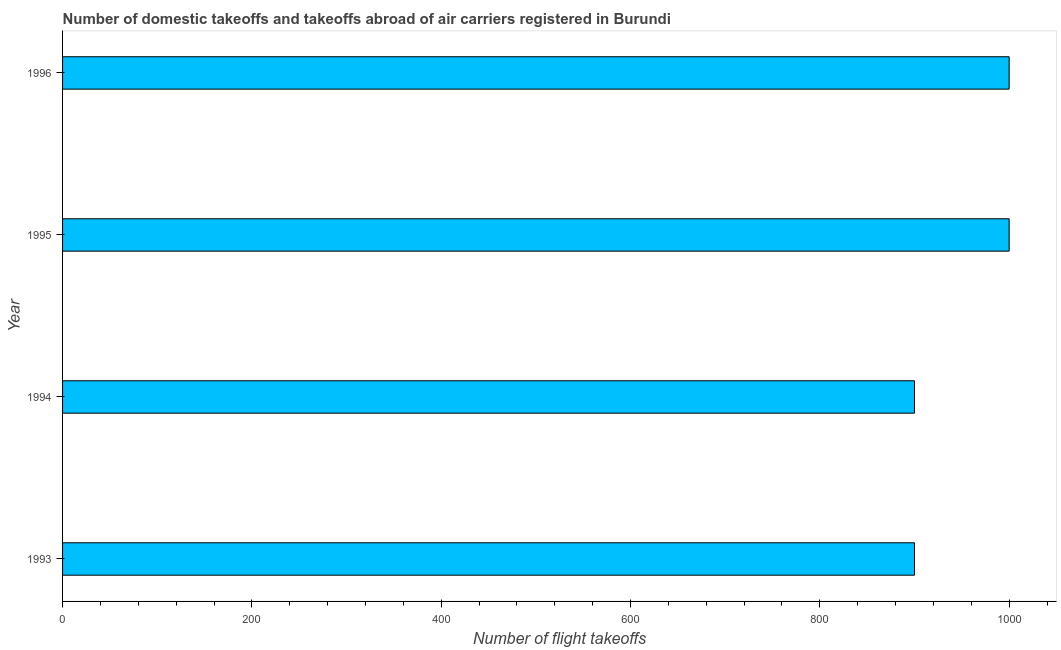What is the title of the graph?
Provide a succinct answer. Number of domestic takeoffs and takeoffs abroad of air carriers registered in Burundi. What is the label or title of the X-axis?
Make the answer very short. Number of flight takeoffs. What is the label or title of the Y-axis?
Your answer should be compact. Year. What is the number of flight takeoffs in 1993?
Your answer should be compact. 900. Across all years, what is the maximum number of flight takeoffs?
Offer a terse response. 1000. Across all years, what is the minimum number of flight takeoffs?
Make the answer very short. 900. In which year was the number of flight takeoffs maximum?
Make the answer very short. 1995. In which year was the number of flight takeoffs minimum?
Your answer should be very brief. 1993. What is the sum of the number of flight takeoffs?
Offer a terse response. 3800. What is the difference between the number of flight takeoffs in 1994 and 1996?
Keep it short and to the point. -100. What is the average number of flight takeoffs per year?
Provide a succinct answer. 950. What is the median number of flight takeoffs?
Offer a very short reply. 950. In how many years, is the number of flight takeoffs greater than 760 ?
Make the answer very short. 4. Do a majority of the years between 1995 and 1994 (inclusive) have number of flight takeoffs greater than 920 ?
Keep it short and to the point. No. What is the ratio of the number of flight takeoffs in 1995 to that in 1996?
Give a very brief answer. 1. Is the number of flight takeoffs in 1993 less than that in 1996?
Make the answer very short. Yes. How many bars are there?
Make the answer very short. 4. What is the difference between two consecutive major ticks on the X-axis?
Ensure brevity in your answer.  200. What is the Number of flight takeoffs of 1993?
Give a very brief answer. 900. What is the Number of flight takeoffs in 1994?
Make the answer very short. 900. What is the Number of flight takeoffs of 1995?
Provide a succinct answer. 1000. What is the Number of flight takeoffs in 1996?
Ensure brevity in your answer.  1000. What is the difference between the Number of flight takeoffs in 1993 and 1995?
Your answer should be very brief. -100. What is the difference between the Number of flight takeoffs in 1993 and 1996?
Your response must be concise. -100. What is the difference between the Number of flight takeoffs in 1994 and 1995?
Provide a succinct answer. -100. What is the difference between the Number of flight takeoffs in 1994 and 1996?
Your response must be concise. -100. What is the difference between the Number of flight takeoffs in 1995 and 1996?
Your response must be concise. 0. What is the ratio of the Number of flight takeoffs in 1993 to that in 1995?
Provide a short and direct response. 0.9. What is the ratio of the Number of flight takeoffs in 1993 to that in 1996?
Provide a succinct answer. 0.9. What is the ratio of the Number of flight takeoffs in 1994 to that in 1995?
Ensure brevity in your answer.  0.9. What is the ratio of the Number of flight takeoffs in 1994 to that in 1996?
Provide a short and direct response. 0.9. 